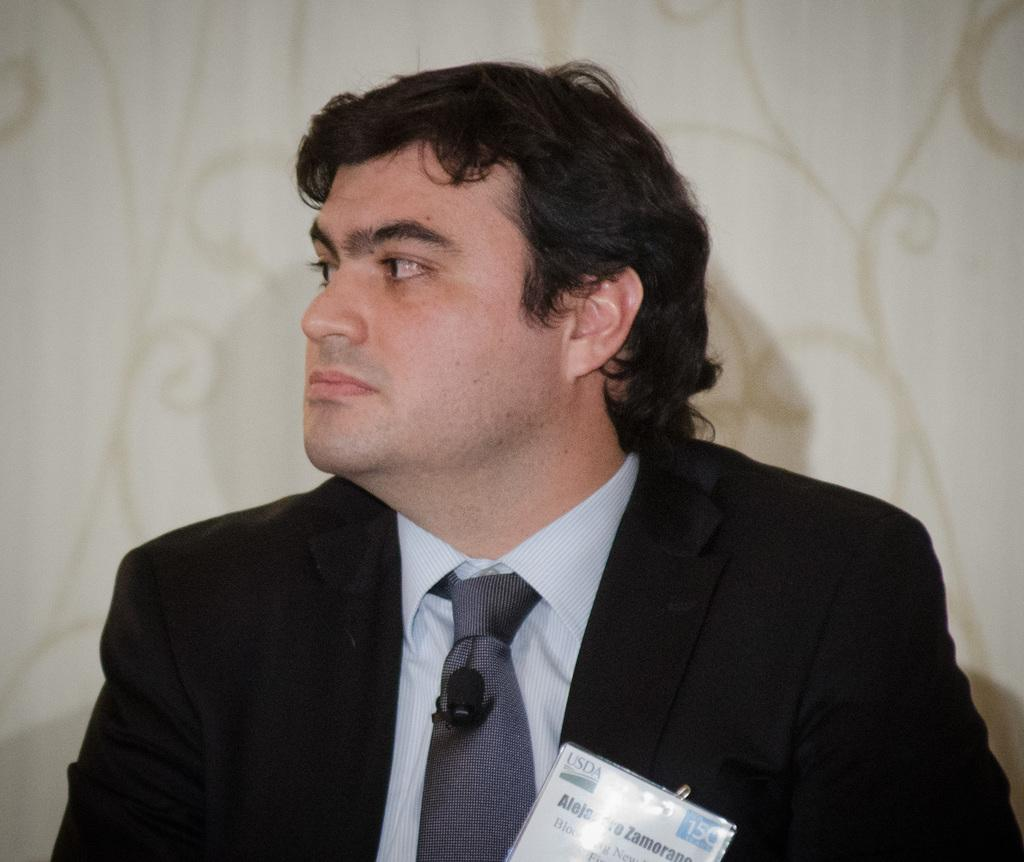Who or what is present in the image? There is a person in the image. What is the person wearing? The person is wearing a black suit. What color is the background of the image? The background of the image is white. How many dogs are visible in the image? There are no dogs present in the image. What type of industry is depicted in the background of the image? There is no industry depicted in the image; the background is white. 